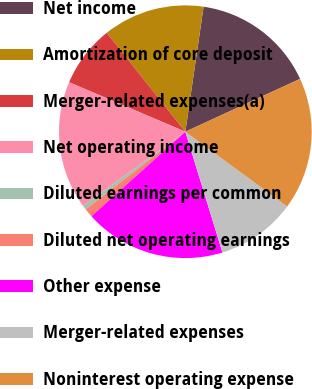<chart> <loc_0><loc_0><loc_500><loc_500><pie_chart><fcel>Net income<fcel>Amortization of core deposit<fcel>Merger-related expenses(a)<fcel>Net operating income<fcel>Diluted earnings per common<fcel>Diluted net operating earnings<fcel>Other expense<fcel>Merger-related expenses<fcel>Noninterest operating expense<nl><fcel>15.82%<fcel>12.99%<fcel>7.91%<fcel>16.38%<fcel>0.56%<fcel>1.13%<fcel>18.08%<fcel>10.17%<fcel>16.95%<nl></chart> 